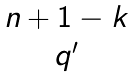Convert formula to latex. <formula><loc_0><loc_0><loc_500><loc_500>\begin{matrix} n + 1 - k \\ q ^ { \prime } \end{matrix}</formula> 